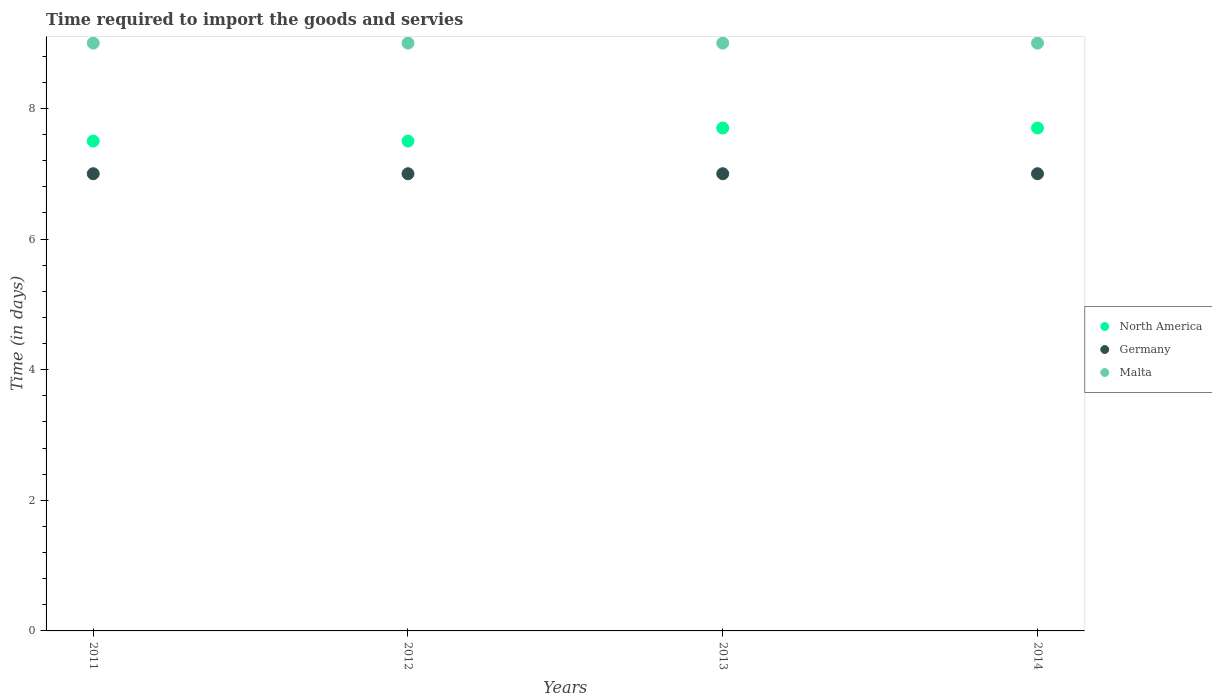How many different coloured dotlines are there?
Give a very brief answer. 3. Is the number of dotlines equal to the number of legend labels?
Give a very brief answer. Yes. What is the number of days required to import the goods and services in North America in 2012?
Provide a succinct answer. 7.5. Across all years, what is the maximum number of days required to import the goods and services in Germany?
Your answer should be very brief. 7. In which year was the number of days required to import the goods and services in Malta minimum?
Your response must be concise. 2011. What is the total number of days required to import the goods and services in Germany in the graph?
Keep it short and to the point. 28. What is the average number of days required to import the goods and services in Malta per year?
Your response must be concise. 9. In the year 2012, what is the difference between the number of days required to import the goods and services in Germany and number of days required to import the goods and services in North America?
Offer a very short reply. -0.5. In how many years, is the number of days required to import the goods and services in North America greater than 2 days?
Ensure brevity in your answer.  4. What is the ratio of the number of days required to import the goods and services in Malta in 2011 to that in 2014?
Give a very brief answer. 1. Is the number of days required to import the goods and services in Malta in 2011 less than that in 2012?
Provide a short and direct response. No. Is the difference between the number of days required to import the goods and services in Germany in 2012 and 2013 greater than the difference between the number of days required to import the goods and services in North America in 2012 and 2013?
Keep it short and to the point. Yes. What is the difference between the highest and the second highest number of days required to import the goods and services in Germany?
Provide a short and direct response. 0. How many dotlines are there?
Your answer should be very brief. 3. Does the graph contain any zero values?
Make the answer very short. No. Where does the legend appear in the graph?
Provide a succinct answer. Center right. How many legend labels are there?
Keep it short and to the point. 3. How are the legend labels stacked?
Your answer should be very brief. Vertical. What is the title of the graph?
Give a very brief answer. Time required to import the goods and servies. What is the label or title of the X-axis?
Your answer should be compact. Years. What is the label or title of the Y-axis?
Keep it short and to the point. Time (in days). What is the Time (in days) in Germany in 2011?
Keep it short and to the point. 7. What is the Time (in days) of Malta in 2011?
Keep it short and to the point. 9. What is the Time (in days) of Malta in 2012?
Offer a terse response. 9. What is the Time (in days) of North America in 2013?
Give a very brief answer. 7.7. What is the Time (in days) in Malta in 2013?
Your answer should be very brief. 9. What is the Time (in days) of North America in 2014?
Give a very brief answer. 7.7. What is the Time (in days) of Malta in 2014?
Make the answer very short. 9. Across all years, what is the maximum Time (in days) in North America?
Ensure brevity in your answer.  7.7. Across all years, what is the maximum Time (in days) of Germany?
Provide a succinct answer. 7. Across all years, what is the minimum Time (in days) in Germany?
Make the answer very short. 7. Across all years, what is the minimum Time (in days) in Malta?
Keep it short and to the point. 9. What is the total Time (in days) in North America in the graph?
Ensure brevity in your answer.  30.4. What is the total Time (in days) in Malta in the graph?
Ensure brevity in your answer.  36. What is the difference between the Time (in days) of North America in 2011 and that in 2012?
Provide a short and direct response. 0. What is the difference between the Time (in days) in Germany in 2011 and that in 2012?
Provide a succinct answer. 0. What is the difference between the Time (in days) of North America in 2011 and that in 2013?
Ensure brevity in your answer.  -0.2. What is the difference between the Time (in days) in North America in 2011 and that in 2014?
Make the answer very short. -0.2. What is the difference between the Time (in days) of Malta in 2011 and that in 2014?
Your answer should be compact. 0. What is the difference between the Time (in days) of Germany in 2012 and that in 2013?
Ensure brevity in your answer.  0. What is the difference between the Time (in days) in Malta in 2012 and that in 2013?
Give a very brief answer. 0. What is the difference between the Time (in days) of Germany in 2012 and that in 2014?
Give a very brief answer. 0. What is the difference between the Time (in days) in Malta in 2012 and that in 2014?
Offer a terse response. 0. What is the difference between the Time (in days) in Germany in 2011 and the Time (in days) in Malta in 2012?
Give a very brief answer. -2. What is the difference between the Time (in days) in Germany in 2011 and the Time (in days) in Malta in 2013?
Provide a short and direct response. -2. What is the difference between the Time (in days) in North America in 2011 and the Time (in days) in Malta in 2014?
Keep it short and to the point. -1.5. What is the difference between the Time (in days) in Germany in 2011 and the Time (in days) in Malta in 2014?
Your answer should be very brief. -2. What is the difference between the Time (in days) in North America in 2012 and the Time (in days) in Germany in 2013?
Give a very brief answer. 0.5. What is the difference between the Time (in days) in Germany in 2012 and the Time (in days) in Malta in 2013?
Ensure brevity in your answer.  -2. What is the difference between the Time (in days) in North America in 2012 and the Time (in days) in Germany in 2014?
Provide a succinct answer. 0.5. What is the difference between the Time (in days) in North America in 2012 and the Time (in days) in Malta in 2014?
Offer a very short reply. -1.5. What is the difference between the Time (in days) in Germany in 2012 and the Time (in days) in Malta in 2014?
Provide a short and direct response. -2. What is the difference between the Time (in days) in North America in 2013 and the Time (in days) in Germany in 2014?
Your response must be concise. 0.7. What is the difference between the Time (in days) of North America in 2013 and the Time (in days) of Malta in 2014?
Offer a terse response. -1.3. What is the difference between the Time (in days) of Germany in 2013 and the Time (in days) of Malta in 2014?
Keep it short and to the point. -2. What is the average Time (in days) of Germany per year?
Offer a terse response. 7. In the year 2011, what is the difference between the Time (in days) of North America and Time (in days) of Malta?
Make the answer very short. -1.5. In the year 2011, what is the difference between the Time (in days) of Germany and Time (in days) of Malta?
Your answer should be very brief. -2. In the year 2012, what is the difference between the Time (in days) in North America and Time (in days) in Malta?
Your answer should be very brief. -1.5. In the year 2013, what is the difference between the Time (in days) in North America and Time (in days) in Malta?
Provide a succinct answer. -1.3. In the year 2013, what is the difference between the Time (in days) of Germany and Time (in days) of Malta?
Ensure brevity in your answer.  -2. In the year 2014, what is the difference between the Time (in days) in Germany and Time (in days) in Malta?
Provide a short and direct response. -2. What is the ratio of the Time (in days) in North America in 2011 to that in 2012?
Your answer should be compact. 1. What is the ratio of the Time (in days) in Malta in 2011 to that in 2012?
Offer a very short reply. 1. What is the ratio of the Time (in days) in North America in 2011 to that in 2013?
Provide a succinct answer. 0.97. What is the ratio of the Time (in days) of Malta in 2011 to that in 2013?
Give a very brief answer. 1. What is the ratio of the Time (in days) of North America in 2011 to that in 2014?
Offer a terse response. 0.97. What is the ratio of the Time (in days) in Malta in 2012 to that in 2013?
Provide a short and direct response. 1. What is the ratio of the Time (in days) in North America in 2012 to that in 2014?
Provide a short and direct response. 0.97. What is the ratio of the Time (in days) in North America in 2013 to that in 2014?
Keep it short and to the point. 1. What is the ratio of the Time (in days) of Germany in 2013 to that in 2014?
Make the answer very short. 1. What is the difference between the highest and the second highest Time (in days) in Germany?
Make the answer very short. 0. What is the difference between the highest and the second highest Time (in days) of Malta?
Your answer should be very brief. 0. What is the difference between the highest and the lowest Time (in days) of North America?
Make the answer very short. 0.2. 